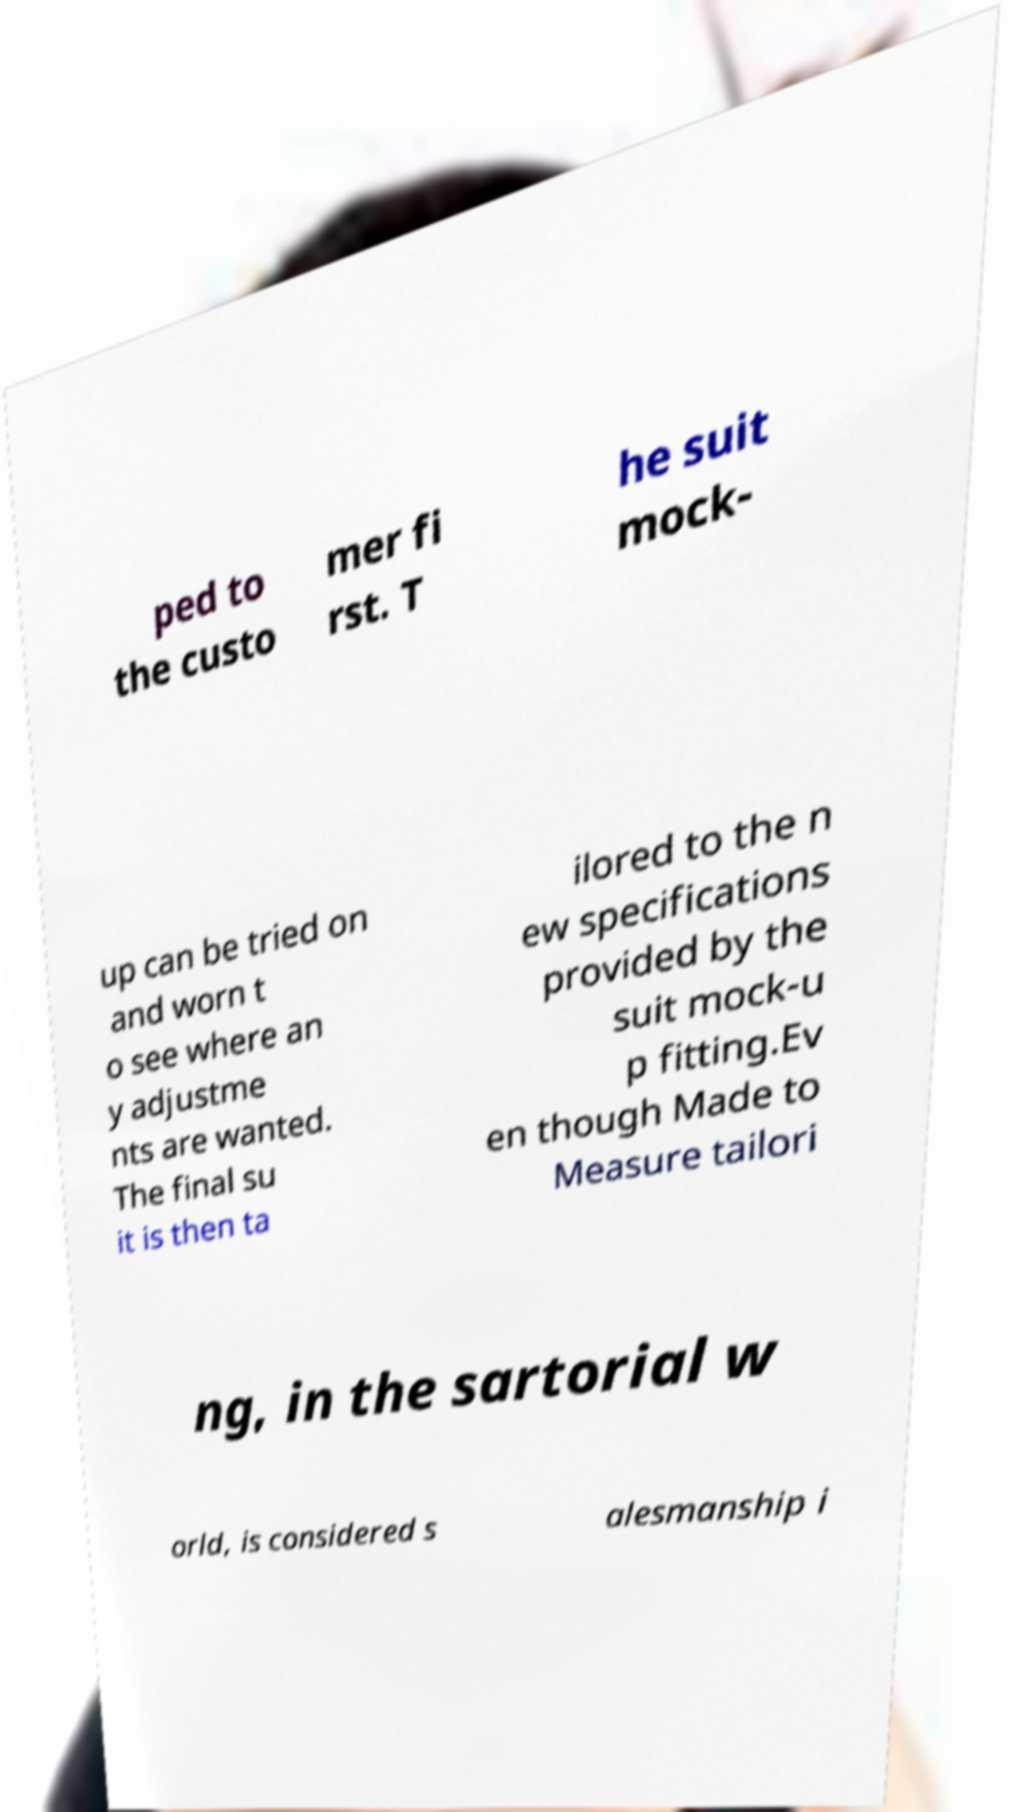Can you read and provide the text displayed in the image?This photo seems to have some interesting text. Can you extract and type it out for me? ped to the custo mer fi rst. T he suit mock- up can be tried on and worn t o see where an y adjustme nts are wanted. The final su it is then ta ilored to the n ew specifications provided by the suit mock-u p fitting.Ev en though Made to Measure tailori ng, in the sartorial w orld, is considered s alesmanship i 